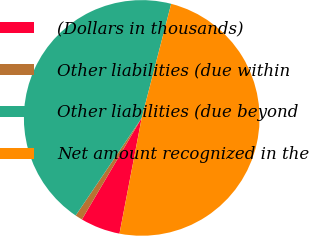<chart> <loc_0><loc_0><loc_500><loc_500><pie_chart><fcel>(Dollars in thousands)<fcel>Other liabilities (due within<fcel>Other liabilities (due beyond<fcel>Net amount recognized in the<nl><fcel>5.45%<fcel>1.0%<fcel>44.55%<fcel>49.0%<nl></chart> 